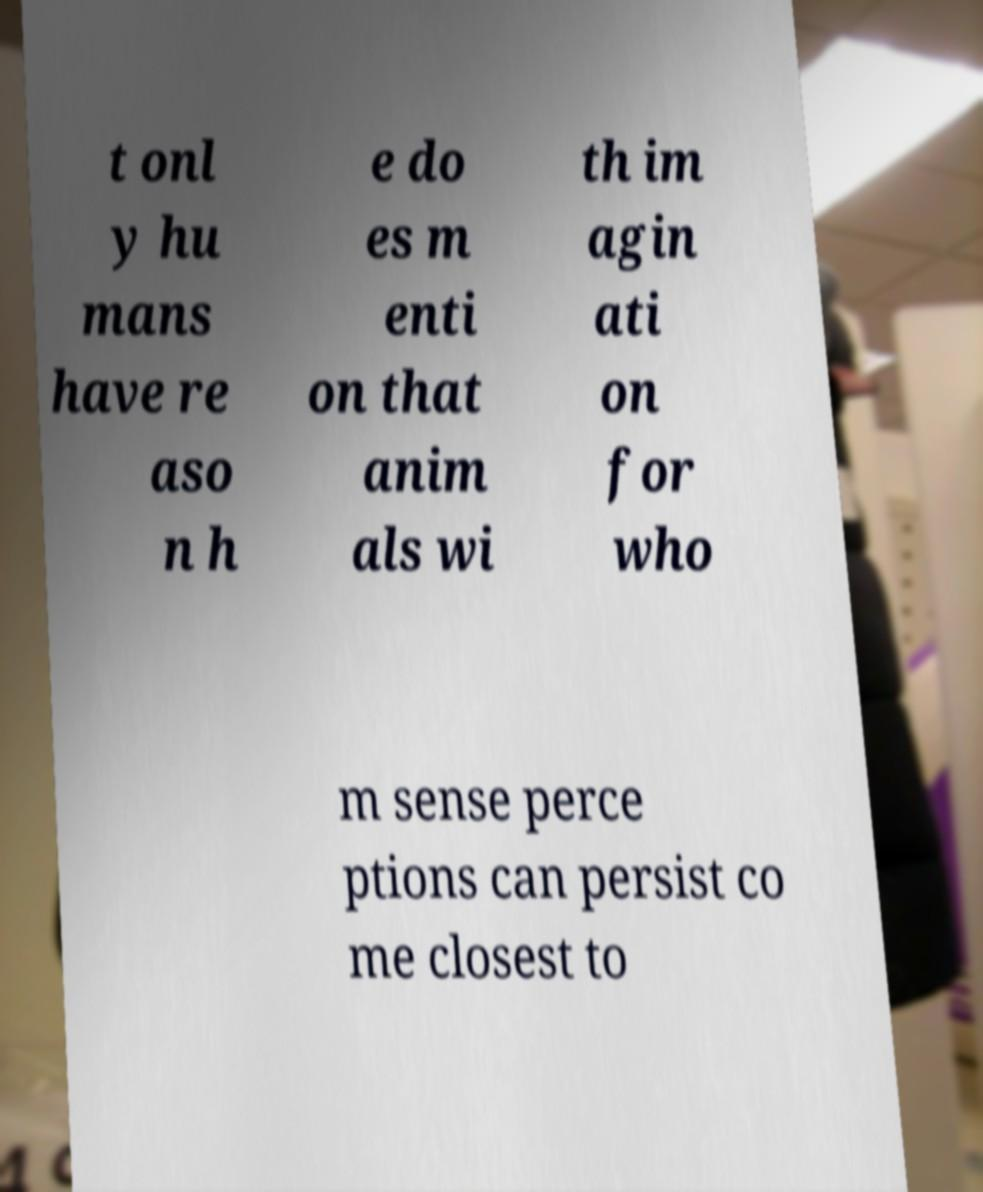Could you extract and type out the text from this image? t onl y hu mans have re aso n h e do es m enti on that anim als wi th im agin ati on for who m sense perce ptions can persist co me closest to 